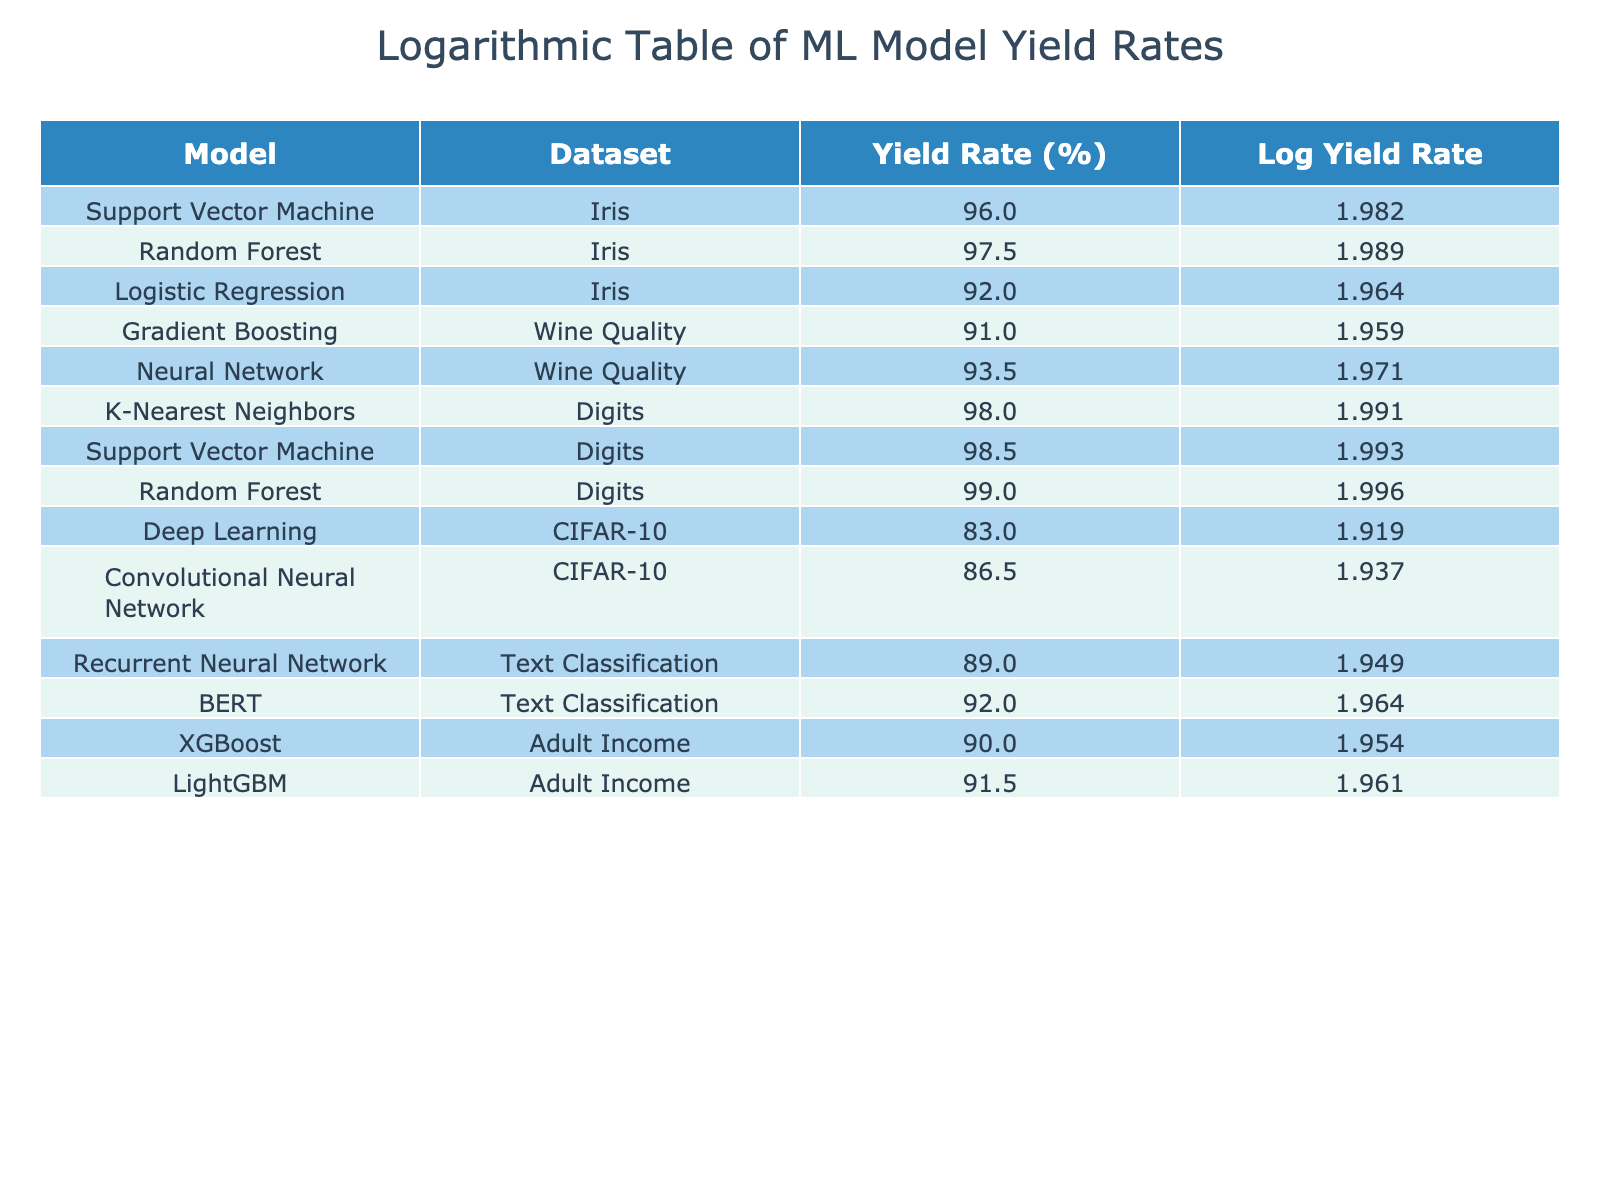What model has the highest yield rate? By examining the "Yield Rate (%)" column in the table, we identify that the Random Forest model applied to the Digits dataset has a yield rate of 99.0%, which is the highest listed.
Answer: Random Forest, Digits, 99.0% What is the yield rate for the Neural Network model on the Wine Quality dataset? The table shows a yield rate of 93.5% for the Neural Network model when applied to the Wine Quality dataset.
Answer: 93.5% How many models achieved a yield rate of 90% or higher? By counting the models listed with a yield rate of 90% or above, we find that there are 7 models: Support Vector Machine, Random Forest, Logistic Regression, Neural Network, Random Forest (Digits), and the models from Adult Income.
Answer: 7 What is the difference in yield rate between the highest and lowest models on the CIFAR-10 dataset? The highest yield rate for a model on the CIFAR-10 dataset is 86.5% for the Convolutional Neural Network, while the lowest is 83.0% for the Deep Learning model. The difference is calculated as 86.5% - 83.0% = 3.5%.
Answer: 3.5% Is the Yield Rate of BERT higher than that of the Logistic Regression model? The Yield Rate for BERT on Text Classification is 92.0%, while Logistic Regression on Iris has a yield rate of 92.0%. Since both rates are equal, the statement is false.
Answer: No 